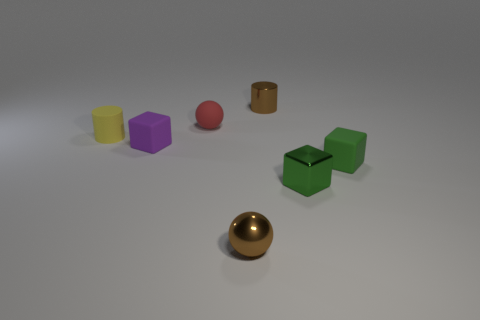There is an object that is both to the left of the tiny brown cylinder and in front of the purple block; what is its size? The golden sphere that is positioned to the left of the tiny brown cylinder and in front of the purple block appears to be small, similar in size to the other small objects visible in the image. 